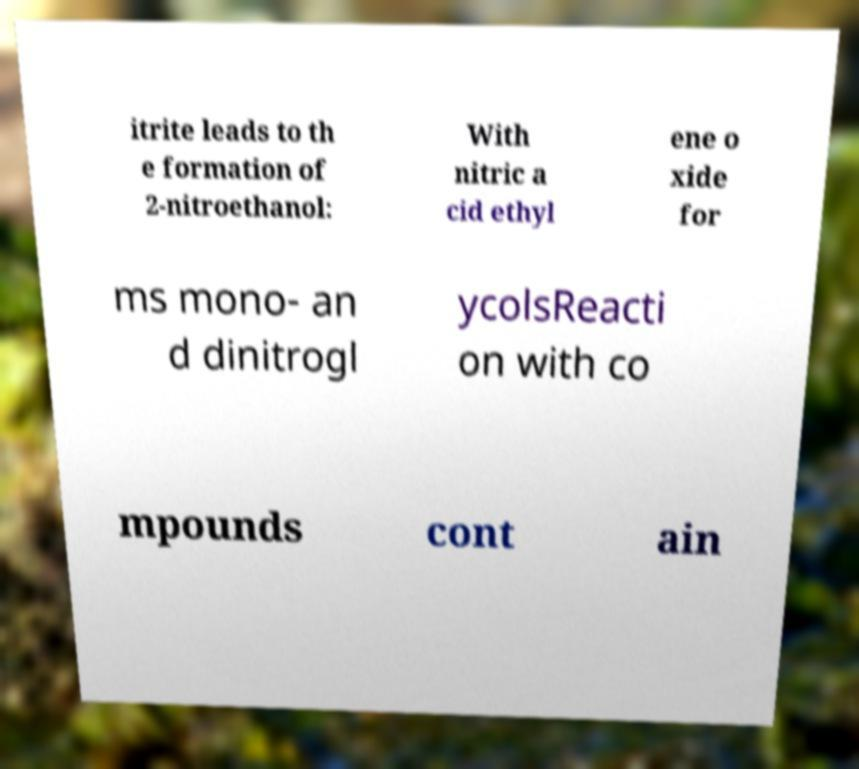For documentation purposes, I need the text within this image transcribed. Could you provide that? itrite leads to th e formation of 2-nitroethanol: With nitric a cid ethyl ene o xide for ms mono- an d dinitrogl ycolsReacti on with co mpounds cont ain 